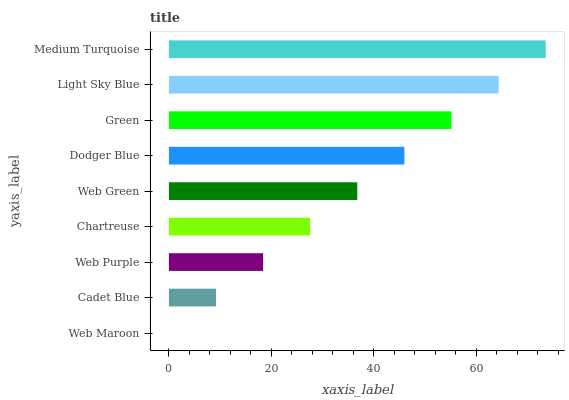Is Web Maroon the minimum?
Answer yes or no. Yes. Is Medium Turquoise the maximum?
Answer yes or no. Yes. Is Cadet Blue the minimum?
Answer yes or no. No. Is Cadet Blue the maximum?
Answer yes or no. No. Is Cadet Blue greater than Web Maroon?
Answer yes or no. Yes. Is Web Maroon less than Cadet Blue?
Answer yes or no. Yes. Is Web Maroon greater than Cadet Blue?
Answer yes or no. No. Is Cadet Blue less than Web Maroon?
Answer yes or no. No. Is Web Green the high median?
Answer yes or no. Yes. Is Web Green the low median?
Answer yes or no. Yes. Is Dodger Blue the high median?
Answer yes or no. No. Is Green the low median?
Answer yes or no. No. 